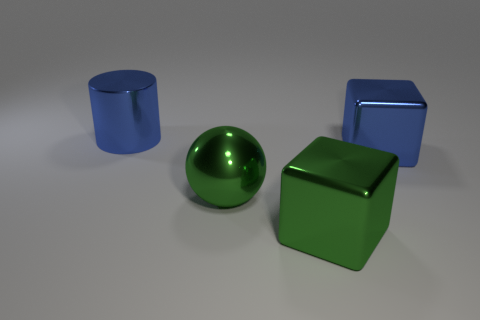How many shiny objects are either small red objects or big cylinders?
Provide a short and direct response. 1. Are there more things that are behind the big metallic sphere than small gray blocks?
Keep it short and to the point. Yes. What number of cubes are in front of the large green shiny sphere and behind the big green metallic sphere?
Ensure brevity in your answer.  0. The shiny block that is behind the large cube that is to the left of the blue cube is what color?
Provide a succinct answer. Blue. How many metal cubes are the same color as the metallic cylinder?
Ensure brevity in your answer.  1. There is a metal cylinder; is it the same color as the large metallic block behind the green sphere?
Provide a succinct answer. Yes. Are there fewer cylinders than large purple matte cubes?
Your answer should be very brief. No. Is the number of blocks in front of the blue metal cylinder greater than the number of metal things to the left of the big green cube?
Your answer should be very brief. No. Does the blue cylinder have the same material as the green ball?
Give a very brief answer. Yes. There is a large block that is in front of the blue metallic block; how many green balls are to the right of it?
Make the answer very short. 0. 